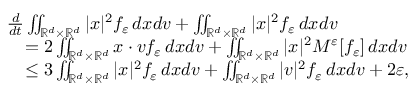Convert formula to latex. <formula><loc_0><loc_0><loc_500><loc_500>\begin{array} { r } { \begin{array} { r l } & { \frac { d } { d t } \iint _ { \mathbb { R } ^ { d } \times \mathbb { R } ^ { d } } | x | ^ { 2 } f _ { \varepsilon } \, d x d v + \iint _ { \mathbb { R } ^ { d } \times \mathbb { R } ^ { d } } | x | ^ { 2 } f _ { \varepsilon } \, d x d v } \\ & { \quad = 2 \iint _ { \mathbb { R } ^ { d } \times \mathbb { R } ^ { d } } x \cdot v f _ { \varepsilon } \, d x d v + \iint _ { \mathbb { R } ^ { d } \times \mathbb { R } ^ { d } } | x | ^ { 2 } M ^ { \varepsilon } [ f _ { \varepsilon } ] \, d x d v } \\ & { \quad \leq 3 \iint _ { \mathbb { R } ^ { d } \times \mathbb { R } ^ { d } } | x | ^ { 2 } f _ { \varepsilon } \, d x d v + \iint _ { \mathbb { R } ^ { d } \times \mathbb { R } ^ { d } } | v | ^ { 2 } f _ { \varepsilon } \, d x d v + 2 \varepsilon , } \end{array} } \end{array}</formula> 